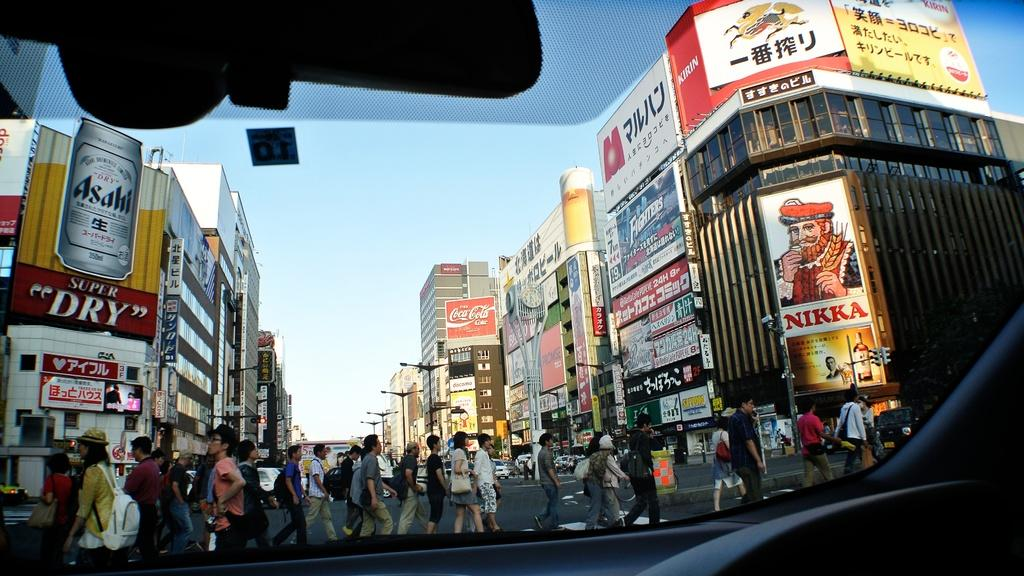What types of objects are present in the image? There are vehicles, a group of people walking on the road, and banners in the image. What can be observed about the buildings in the image? The buildings in the image have windows. What are the poles used for in the image? The poles in the image might be used for supporting banners or other objects. What is visible in the background of the image? The sky is visible in the background of the image. What type of apple is being used as a decoration on the banners in the image? There are no apples present in the image; the banners do not have any apple decorations. What emotion can be seen on the faces of the people walking on the road in the image? The image does not show the faces of the people walking on the road, so it is not possible to determine their emotions. 